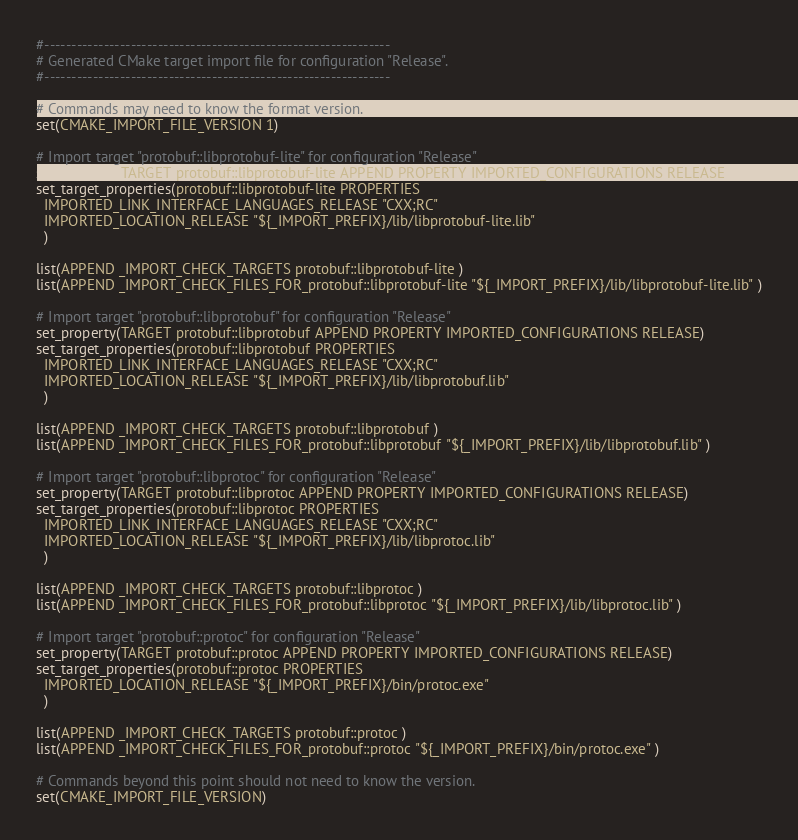<code> <loc_0><loc_0><loc_500><loc_500><_CMake_>#----------------------------------------------------------------
# Generated CMake target import file for configuration "Release".
#----------------------------------------------------------------

# Commands may need to know the format version.
set(CMAKE_IMPORT_FILE_VERSION 1)

# Import target "protobuf::libprotobuf-lite" for configuration "Release"
set_property(TARGET protobuf::libprotobuf-lite APPEND PROPERTY IMPORTED_CONFIGURATIONS RELEASE)
set_target_properties(protobuf::libprotobuf-lite PROPERTIES
  IMPORTED_LINK_INTERFACE_LANGUAGES_RELEASE "CXX;RC"
  IMPORTED_LOCATION_RELEASE "${_IMPORT_PREFIX}/lib/libprotobuf-lite.lib"
  )

list(APPEND _IMPORT_CHECK_TARGETS protobuf::libprotobuf-lite )
list(APPEND _IMPORT_CHECK_FILES_FOR_protobuf::libprotobuf-lite "${_IMPORT_PREFIX}/lib/libprotobuf-lite.lib" )

# Import target "protobuf::libprotobuf" for configuration "Release"
set_property(TARGET protobuf::libprotobuf APPEND PROPERTY IMPORTED_CONFIGURATIONS RELEASE)
set_target_properties(protobuf::libprotobuf PROPERTIES
  IMPORTED_LINK_INTERFACE_LANGUAGES_RELEASE "CXX;RC"
  IMPORTED_LOCATION_RELEASE "${_IMPORT_PREFIX}/lib/libprotobuf.lib"
  )

list(APPEND _IMPORT_CHECK_TARGETS protobuf::libprotobuf )
list(APPEND _IMPORT_CHECK_FILES_FOR_protobuf::libprotobuf "${_IMPORT_PREFIX}/lib/libprotobuf.lib" )

# Import target "protobuf::libprotoc" for configuration "Release"
set_property(TARGET protobuf::libprotoc APPEND PROPERTY IMPORTED_CONFIGURATIONS RELEASE)
set_target_properties(protobuf::libprotoc PROPERTIES
  IMPORTED_LINK_INTERFACE_LANGUAGES_RELEASE "CXX;RC"
  IMPORTED_LOCATION_RELEASE "${_IMPORT_PREFIX}/lib/libprotoc.lib"
  )

list(APPEND _IMPORT_CHECK_TARGETS protobuf::libprotoc )
list(APPEND _IMPORT_CHECK_FILES_FOR_protobuf::libprotoc "${_IMPORT_PREFIX}/lib/libprotoc.lib" )

# Import target "protobuf::protoc" for configuration "Release"
set_property(TARGET protobuf::protoc APPEND PROPERTY IMPORTED_CONFIGURATIONS RELEASE)
set_target_properties(protobuf::protoc PROPERTIES
  IMPORTED_LOCATION_RELEASE "${_IMPORT_PREFIX}/bin/protoc.exe"
  )

list(APPEND _IMPORT_CHECK_TARGETS protobuf::protoc )
list(APPEND _IMPORT_CHECK_FILES_FOR_protobuf::protoc "${_IMPORT_PREFIX}/bin/protoc.exe" )

# Commands beyond this point should not need to know the version.
set(CMAKE_IMPORT_FILE_VERSION)
</code> 